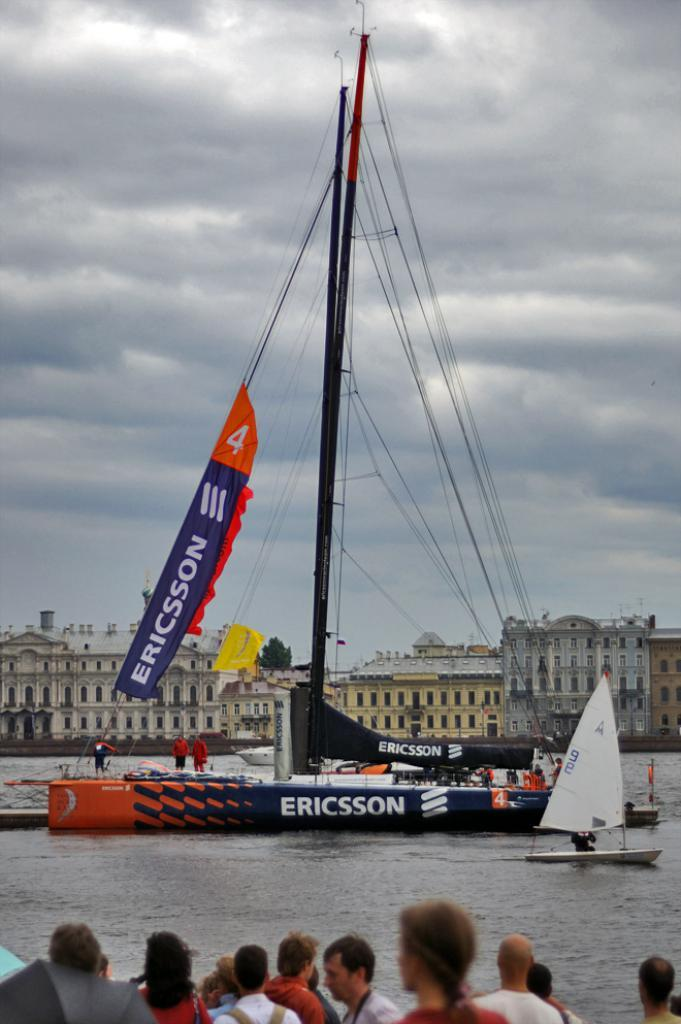What is the main subject in the image? There is a ship in the image. What is the ship located on or near? The ship is located on water, which is visible in the image. What can be seen in the background of the image? There are buildings visible in the background of the image. Are there any people present in the image? Yes, there are people standing near the water in the image. What type of bean is growing in the field next to the ship in the image? There is no field or bean present in the image; it features a ship on water with buildings in the background and people standing near the water. 